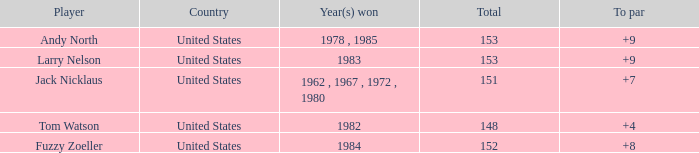What is the Country of the Player with a Total less than 153 and Year(s) won of 1984? United States. 